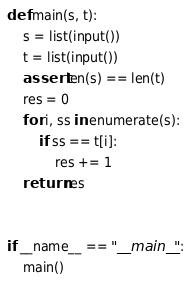<code> <loc_0><loc_0><loc_500><loc_500><_Python_>def main(s, t):
    s = list(input())
    t = list(input())
    assert len(s) == len(t)
    res = 0
    for i, ss in enumerate(s):
        if ss == t[i]:
            res += 1
    return res


if __name__ == "__main__":
    main()
</code> 